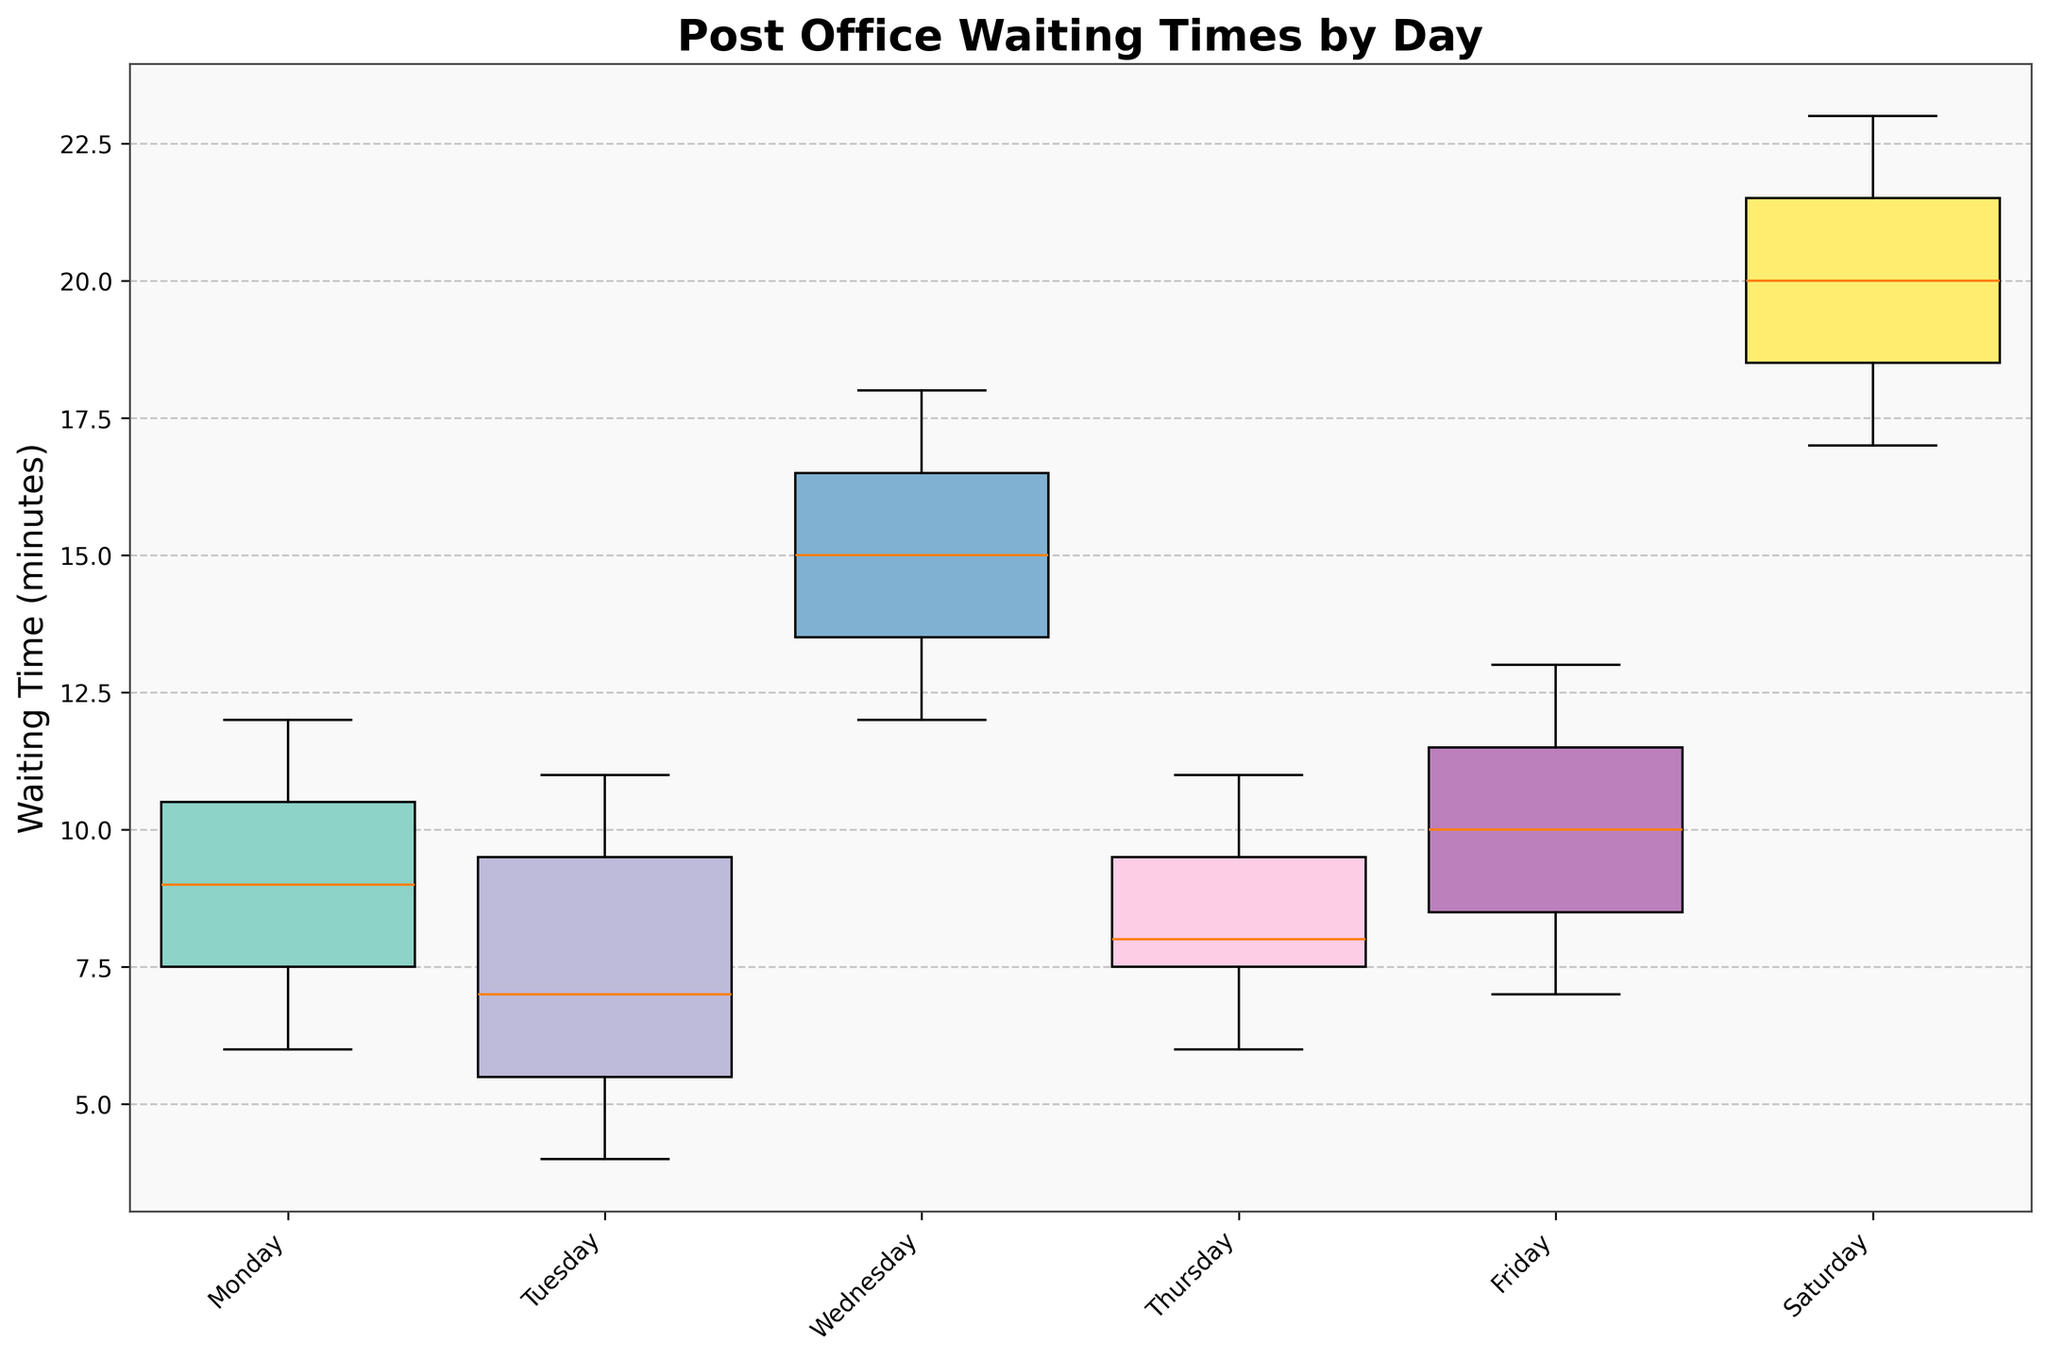What is the title of the figure? The title is located at the top of the figure. It helps to understand what the figure is about. Here, it tells us that the plot is about waiting times at the post office segmented by day.
Answer: Post Office Waiting Times by Day Which day has the widest spread in waiting times? To find this, look at the box width for each day. A wider box indicates a larger spread.
Answer: Saturday On which day is the median waiting time the highest? For this, locate the median line within each box plot. The highest median line represents the highest median waiting time.
Answer: Saturday List the days in order from the shortest to the longest median waiting time. Look at the median line within each box plot and order them accordingly from the lowest to the highest.
Answer: Tuesday, Monday, Thursday, Friday, Wednesday, Saturday What is the interquartile range (IQR) for Friday? Find the distance between the first quartile (bottom edge of the box) and the third quartile (top edge of the box) for Friday. This is the interquartile range (IQR).
Answer: 6 to 11 minutes (IQR is 5 minutes) Which days show the smallest variability in waiting times? Small variability is indicated by lower boxes and shorter whiskers. Compare the box plots for all days to identify this.
Answer: Monday, Tuesday, Thursday Is there any day where the waiting times have no outliers? Outliers are usually indicated by points outside the whiskers. Check if there is a day with no points beyond the whiskers.
Answer: Monday, Thursday Compare the waiting times for Wednesday and Thursday. Which day has generally higher waiting times? Look at the position of the boxes for Wednesday and Thursday. The higher the box, the higher the waiting times.
Answer: Wednesday What does the width of each box plot represent? In a variable-width box plot, the width represents the number of data points. Wider boxes mean more data points.
Answer: Number of data points Which day has the smallest number of data points? The width of the box plots indicates the number of data points. The narrower the box, the fewer the data points.
Answer: Tuesday 